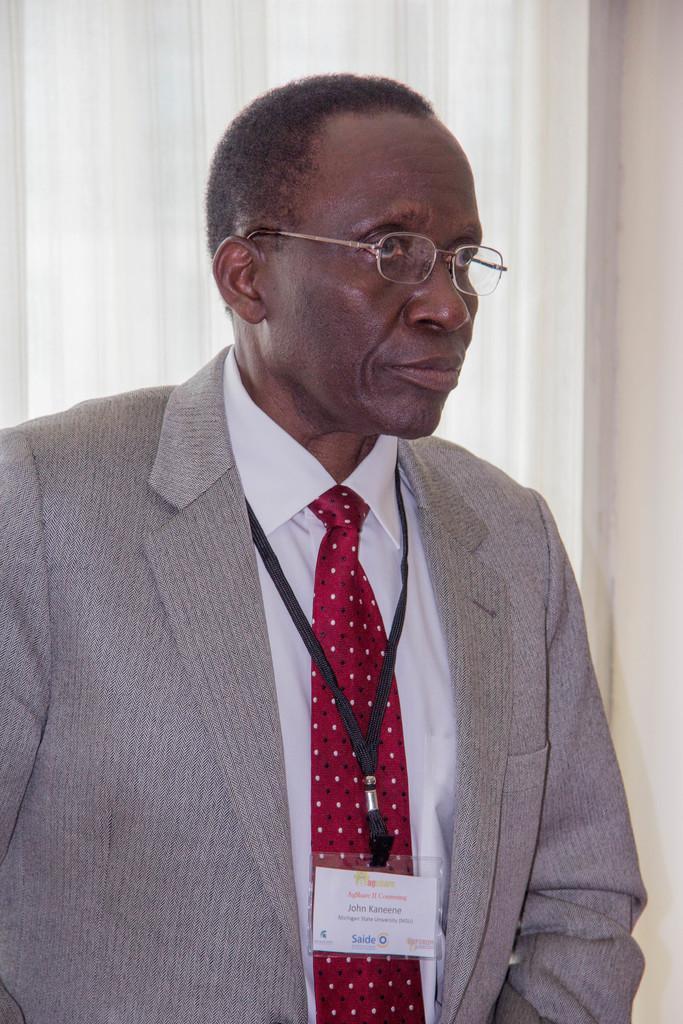In one or two sentences, can you explain what this image depicts? In this image there is a person standing and at the background there are curtains. 